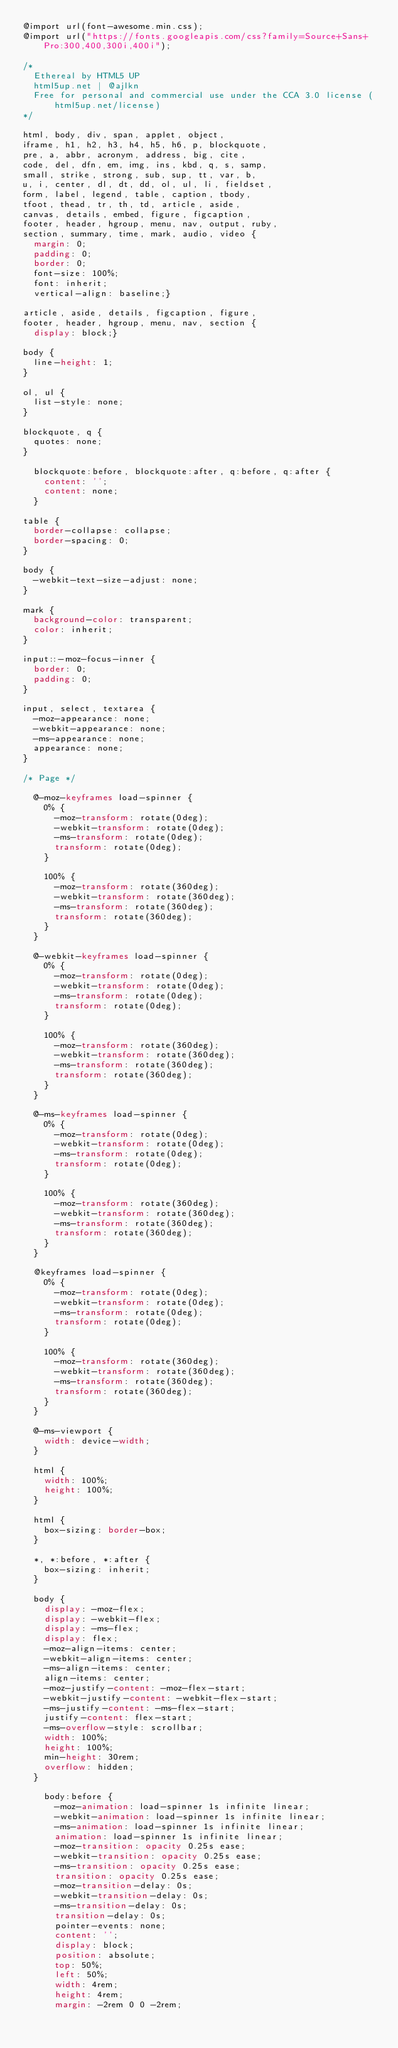Convert code to text. <code><loc_0><loc_0><loc_500><loc_500><_CSS_>@import url(font-awesome.min.css);
@import url("https://fonts.googleapis.com/css?family=Source+Sans+Pro:300,400,300i,400i");

/*
	Ethereal by HTML5 UP
	html5up.net | @ajlkn
	Free for personal and commercial use under the CCA 3.0 license (html5up.net/license)
*/

html, body, div, span, applet, object,
iframe, h1, h2, h3, h4, h5, h6, p, blockquote,
pre, a, abbr, acronym, address, big, cite,
code, del, dfn, em, img, ins, kbd, q, s, samp,
small, strike, strong, sub, sup, tt, var, b,
u, i, center, dl, dt, dd, ol, ul, li, fieldset,
form, label, legend, table, caption, tbody,
tfoot, thead, tr, th, td, article, aside,
canvas, details, embed, figure, figcaption,
footer, header, hgroup, menu, nav, output, ruby,
section, summary, time, mark, audio, video {
	margin: 0;
	padding: 0;
	border: 0;
	font-size: 100%;
	font: inherit;
	vertical-align: baseline;}

article, aside, details, figcaption, figure,
footer, header, hgroup, menu, nav, section {
	display: block;}

body {
	line-height: 1;
}

ol, ul {
	list-style: none;
}

blockquote, q {
	quotes: none;
}

	blockquote:before, blockquote:after, q:before, q:after {
		content: '';
		content: none;
	}

table {
	border-collapse: collapse;
	border-spacing: 0;
}

body {
	-webkit-text-size-adjust: none;
}

mark {
	background-color: transparent;
	color: inherit;
}

input::-moz-focus-inner {
	border: 0;
	padding: 0;
}

input, select, textarea {
	-moz-appearance: none;
	-webkit-appearance: none;
	-ms-appearance: none;
	appearance: none;
}

/* Page */

	@-moz-keyframes load-spinner {
		0% {
			-moz-transform: rotate(0deg);
			-webkit-transform: rotate(0deg);
			-ms-transform: rotate(0deg);
			transform: rotate(0deg);
		}

		100% {
			-moz-transform: rotate(360deg);
			-webkit-transform: rotate(360deg);
			-ms-transform: rotate(360deg);
			transform: rotate(360deg);
		}
	}

	@-webkit-keyframes load-spinner {
		0% {
			-moz-transform: rotate(0deg);
			-webkit-transform: rotate(0deg);
			-ms-transform: rotate(0deg);
			transform: rotate(0deg);
		}

		100% {
			-moz-transform: rotate(360deg);
			-webkit-transform: rotate(360deg);
			-ms-transform: rotate(360deg);
			transform: rotate(360deg);
		}
	}

	@-ms-keyframes load-spinner {
		0% {
			-moz-transform: rotate(0deg);
			-webkit-transform: rotate(0deg);
			-ms-transform: rotate(0deg);
			transform: rotate(0deg);
		}

		100% {
			-moz-transform: rotate(360deg);
			-webkit-transform: rotate(360deg);
			-ms-transform: rotate(360deg);
			transform: rotate(360deg);
		}
	}

	@keyframes load-spinner {
		0% {
			-moz-transform: rotate(0deg);
			-webkit-transform: rotate(0deg);
			-ms-transform: rotate(0deg);
			transform: rotate(0deg);
		}

		100% {
			-moz-transform: rotate(360deg);
			-webkit-transform: rotate(360deg);
			-ms-transform: rotate(360deg);
			transform: rotate(360deg);
		}
	}

	@-ms-viewport {
		width: device-width;
	}

	html {
		width: 100%;
		height: 100%;
	}

	html {
		box-sizing: border-box;
	}

	*, *:before, *:after {
		box-sizing: inherit;
	}

	body {
		display: -moz-flex;
		display: -webkit-flex;
		display: -ms-flex;
		display: flex;
		-moz-align-items: center;
		-webkit-align-items: center;
		-ms-align-items: center;
		align-items: center;
		-moz-justify-content: -moz-flex-start;
		-webkit-justify-content: -webkit-flex-start;
		-ms-justify-content: -ms-flex-start;
		justify-content: flex-start;
		-ms-overflow-style: scrollbar;
		width: 100%;
		height: 100%;
		min-height: 30rem;
		overflow: hidden;
	}

		body:before {
			-moz-animation: load-spinner 1s infinite linear;
			-webkit-animation: load-spinner 1s infinite linear;
			-ms-animation: load-spinner 1s infinite linear;
			animation: load-spinner 1s infinite linear;
			-moz-transition: opacity 0.25s ease;
			-webkit-transition: opacity 0.25s ease;
			-ms-transition: opacity 0.25s ease;
			transition: opacity 0.25s ease;
			-moz-transition-delay: 0s;
			-webkit-transition-delay: 0s;
			-ms-transition-delay: 0s;
			transition-delay: 0s;
			pointer-events: none;
			content: '';
			display: block;
			position: absolute;
			top: 50%;
			left: 50%;
			width: 4rem;
			height: 4rem;
			margin: -2rem 0 0 -2rem;</code> 